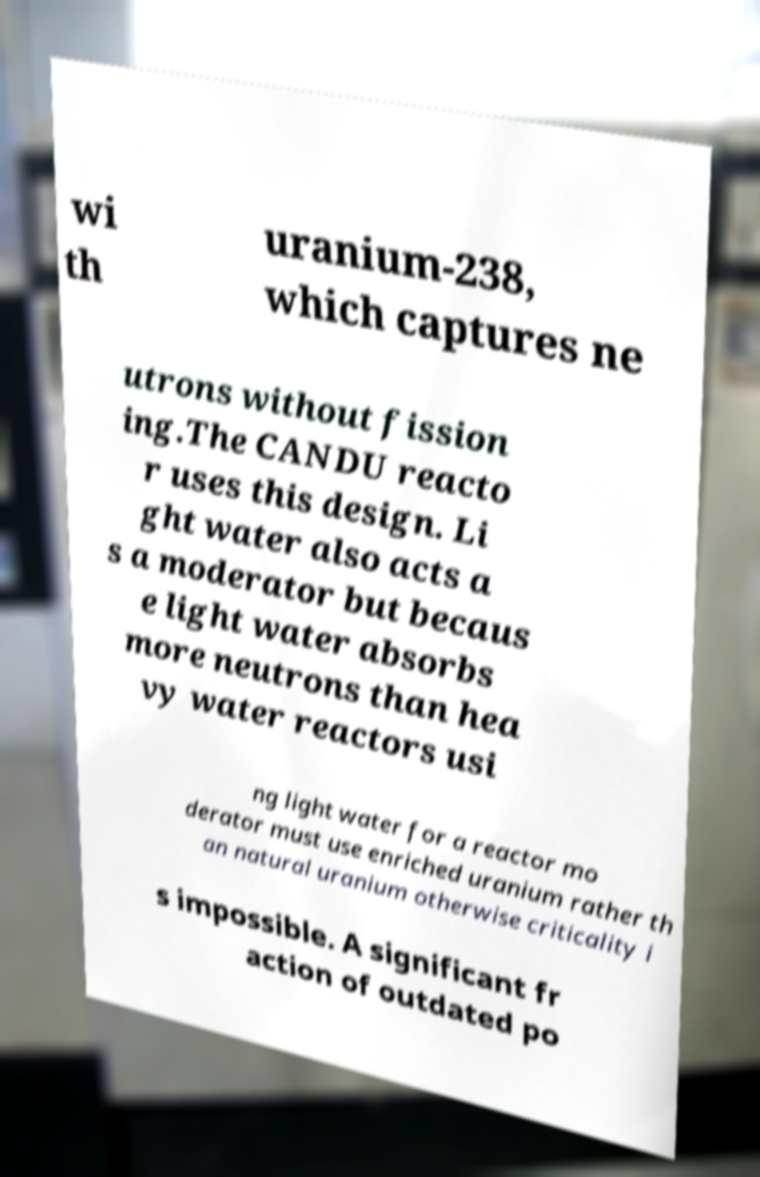There's text embedded in this image that I need extracted. Can you transcribe it verbatim? wi th uranium-238, which captures ne utrons without fission ing.The CANDU reacto r uses this design. Li ght water also acts a s a moderator but becaus e light water absorbs more neutrons than hea vy water reactors usi ng light water for a reactor mo derator must use enriched uranium rather th an natural uranium otherwise criticality i s impossible. A significant fr action of outdated po 